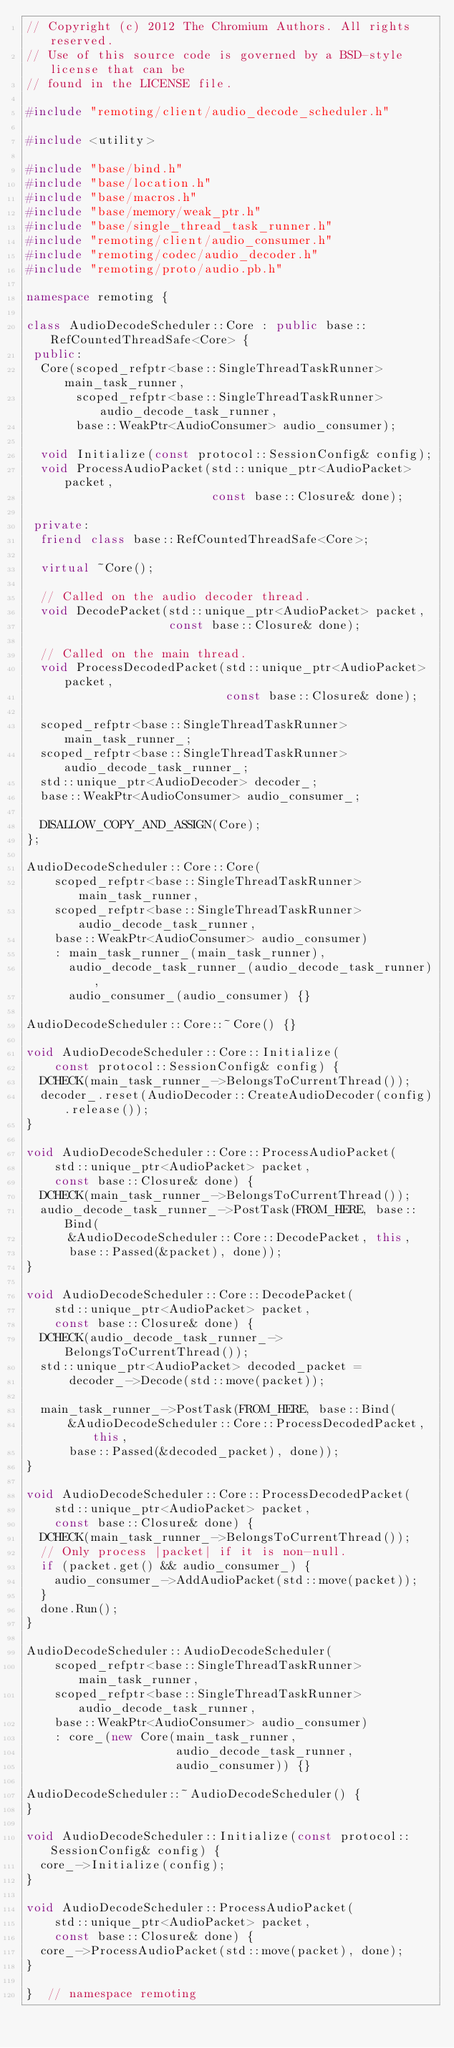Convert code to text. <code><loc_0><loc_0><loc_500><loc_500><_C++_>// Copyright (c) 2012 The Chromium Authors. All rights reserved.
// Use of this source code is governed by a BSD-style license that can be
// found in the LICENSE file.

#include "remoting/client/audio_decode_scheduler.h"

#include <utility>

#include "base/bind.h"
#include "base/location.h"
#include "base/macros.h"
#include "base/memory/weak_ptr.h"
#include "base/single_thread_task_runner.h"
#include "remoting/client/audio_consumer.h"
#include "remoting/codec/audio_decoder.h"
#include "remoting/proto/audio.pb.h"

namespace remoting {

class AudioDecodeScheduler::Core : public base::RefCountedThreadSafe<Core> {
 public:
  Core(scoped_refptr<base::SingleThreadTaskRunner> main_task_runner,
       scoped_refptr<base::SingleThreadTaskRunner> audio_decode_task_runner,
       base::WeakPtr<AudioConsumer> audio_consumer);

  void Initialize(const protocol::SessionConfig& config);
  void ProcessAudioPacket(std::unique_ptr<AudioPacket> packet,
                          const base::Closure& done);

 private:
  friend class base::RefCountedThreadSafe<Core>;

  virtual ~Core();

  // Called on the audio decoder thread.
  void DecodePacket(std::unique_ptr<AudioPacket> packet,
                    const base::Closure& done);

  // Called on the main thread.
  void ProcessDecodedPacket(std::unique_ptr<AudioPacket> packet,
                            const base::Closure& done);

  scoped_refptr<base::SingleThreadTaskRunner> main_task_runner_;
  scoped_refptr<base::SingleThreadTaskRunner> audio_decode_task_runner_;
  std::unique_ptr<AudioDecoder> decoder_;
  base::WeakPtr<AudioConsumer> audio_consumer_;

  DISALLOW_COPY_AND_ASSIGN(Core);
};

AudioDecodeScheduler::Core::Core(
    scoped_refptr<base::SingleThreadTaskRunner> main_task_runner,
    scoped_refptr<base::SingleThreadTaskRunner> audio_decode_task_runner,
    base::WeakPtr<AudioConsumer> audio_consumer)
    : main_task_runner_(main_task_runner),
      audio_decode_task_runner_(audio_decode_task_runner),
      audio_consumer_(audio_consumer) {}

AudioDecodeScheduler::Core::~Core() {}

void AudioDecodeScheduler::Core::Initialize(
    const protocol::SessionConfig& config) {
  DCHECK(main_task_runner_->BelongsToCurrentThread());
  decoder_.reset(AudioDecoder::CreateAudioDecoder(config).release());
}

void AudioDecodeScheduler::Core::ProcessAudioPacket(
    std::unique_ptr<AudioPacket> packet,
    const base::Closure& done) {
  DCHECK(main_task_runner_->BelongsToCurrentThread());
  audio_decode_task_runner_->PostTask(FROM_HERE, base::Bind(
      &AudioDecodeScheduler::Core::DecodePacket, this,
      base::Passed(&packet), done));
}

void AudioDecodeScheduler::Core::DecodePacket(
    std::unique_ptr<AudioPacket> packet,
    const base::Closure& done) {
  DCHECK(audio_decode_task_runner_->BelongsToCurrentThread());
  std::unique_ptr<AudioPacket> decoded_packet =
      decoder_->Decode(std::move(packet));

  main_task_runner_->PostTask(FROM_HERE, base::Bind(
      &AudioDecodeScheduler::Core::ProcessDecodedPacket, this,
      base::Passed(&decoded_packet), done));
}

void AudioDecodeScheduler::Core::ProcessDecodedPacket(
    std::unique_ptr<AudioPacket> packet,
    const base::Closure& done) {
  DCHECK(main_task_runner_->BelongsToCurrentThread());
  // Only process |packet| if it is non-null.
  if (packet.get() && audio_consumer_) {
    audio_consumer_->AddAudioPacket(std::move(packet));
  }
  done.Run();
}

AudioDecodeScheduler::AudioDecodeScheduler(
    scoped_refptr<base::SingleThreadTaskRunner> main_task_runner,
    scoped_refptr<base::SingleThreadTaskRunner> audio_decode_task_runner,
    base::WeakPtr<AudioConsumer> audio_consumer)
    : core_(new Core(main_task_runner,
                     audio_decode_task_runner,
                     audio_consumer)) {}

AudioDecodeScheduler::~AudioDecodeScheduler() {
}

void AudioDecodeScheduler::Initialize(const protocol::SessionConfig& config) {
  core_->Initialize(config);
}

void AudioDecodeScheduler::ProcessAudioPacket(
    std::unique_ptr<AudioPacket> packet,
    const base::Closure& done) {
  core_->ProcessAudioPacket(std::move(packet), done);
}

}  // namespace remoting
</code> 